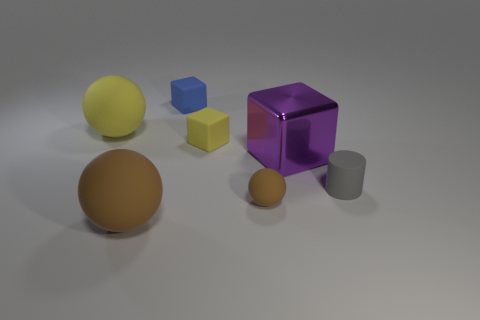Add 2 large brown blocks. How many objects exist? 9 Subtract all spheres. How many objects are left? 4 Add 7 purple metal blocks. How many purple metal blocks are left? 8 Add 2 big spheres. How many big spheres exist? 4 Subtract 0 cyan blocks. How many objects are left? 7 Subtract all tiny gray cylinders. Subtract all tiny rubber balls. How many objects are left? 5 